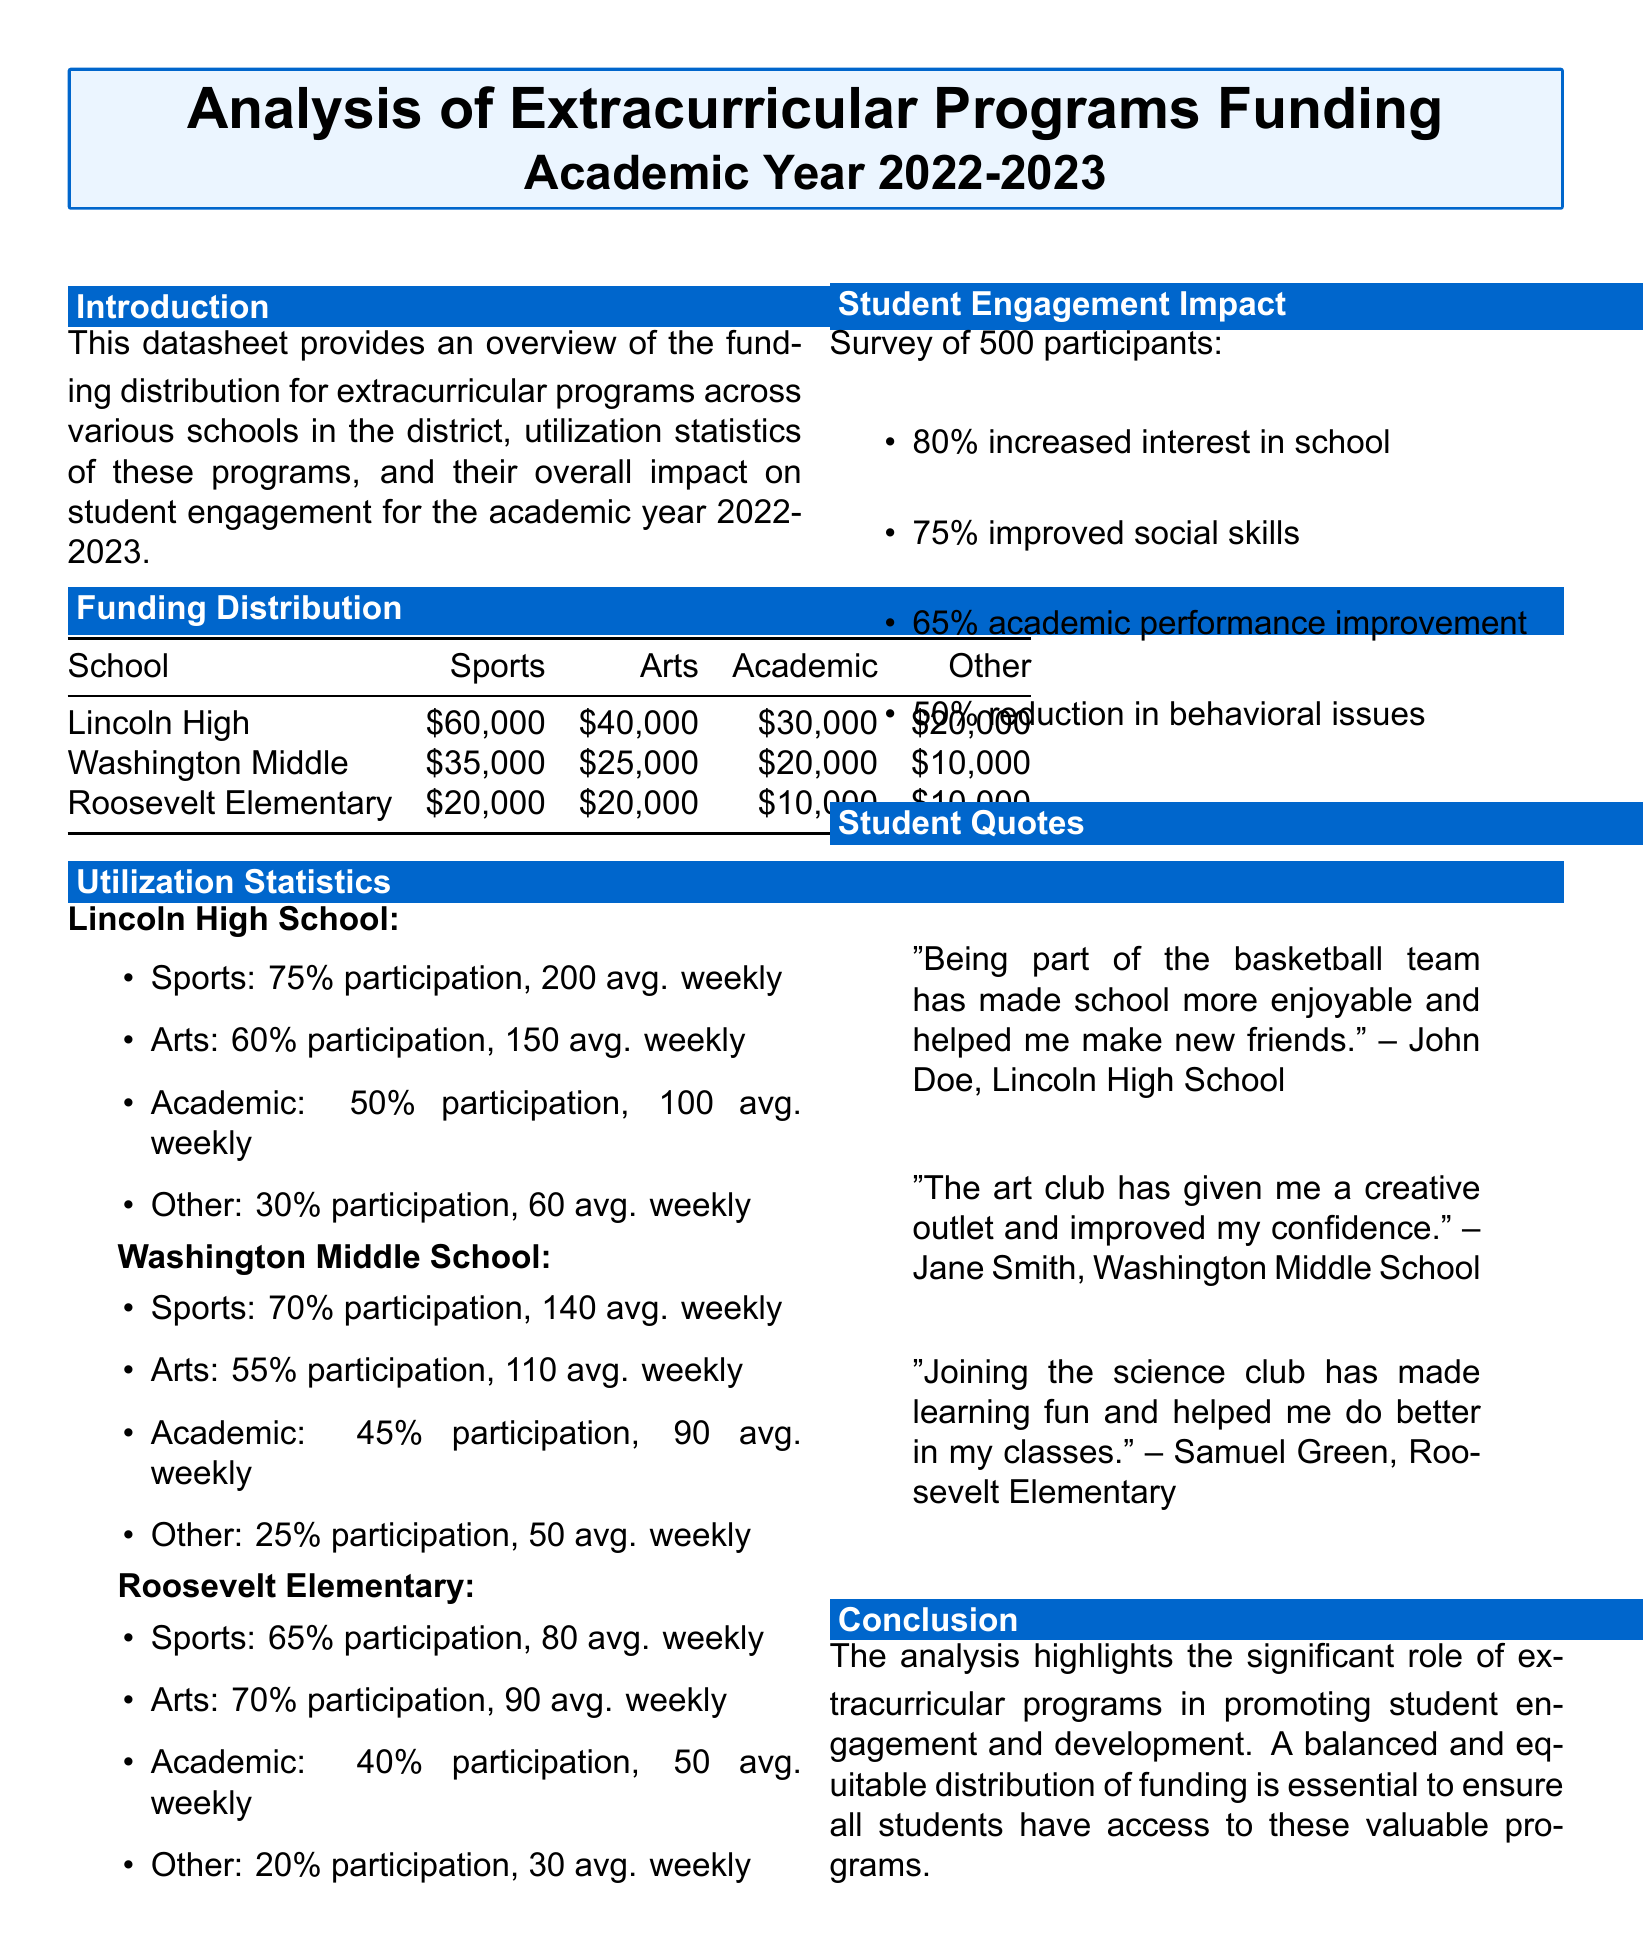What is the total funding for Lincoln High? The total funding is the sum of all categories: $60,000 + $40,000 + $30,000 + $20,000 = $150,000.
Answer: $150,000 What percentage of students participate in sports at Roosevelt Elementary? The document states that 65% of students participate in sports at Roosevelt Elementary.
Answer: 65% How many average participants are there weekly for arts at Washington Middle School? The document indicates that there are 110 average weekly participants for arts at Washington Middle School.
Answer: 110 What percent of surveyed students reported improved social skills? According to the document, 75% of surveyed students reported improved social skills.
Answer: 75% What is the funding amount for academic programs at Washington Middle School? The funding amount for academic programs at Washington Middle School is $20,000.
Answer: $20,000 Which school has the highest funding for sports? Lincoln High School has the highest funding for sports, which is $60,000.
Answer: Lincoln High School What is the impact of extracurricular programs on student interest in school? The document reports that 80% of participants increased their interest in school due to extracurricular programs.
Answer: 80% Which extracurricular program has the lowest participation rate at Lincoln High? The program with the lowest participation rate at Lincoln High is "Other," with 30% participation.
Answer: Other What was the total number of participants surveyed for the engagement impact? The total number of participants surveyed was 500.
Answer: 500 